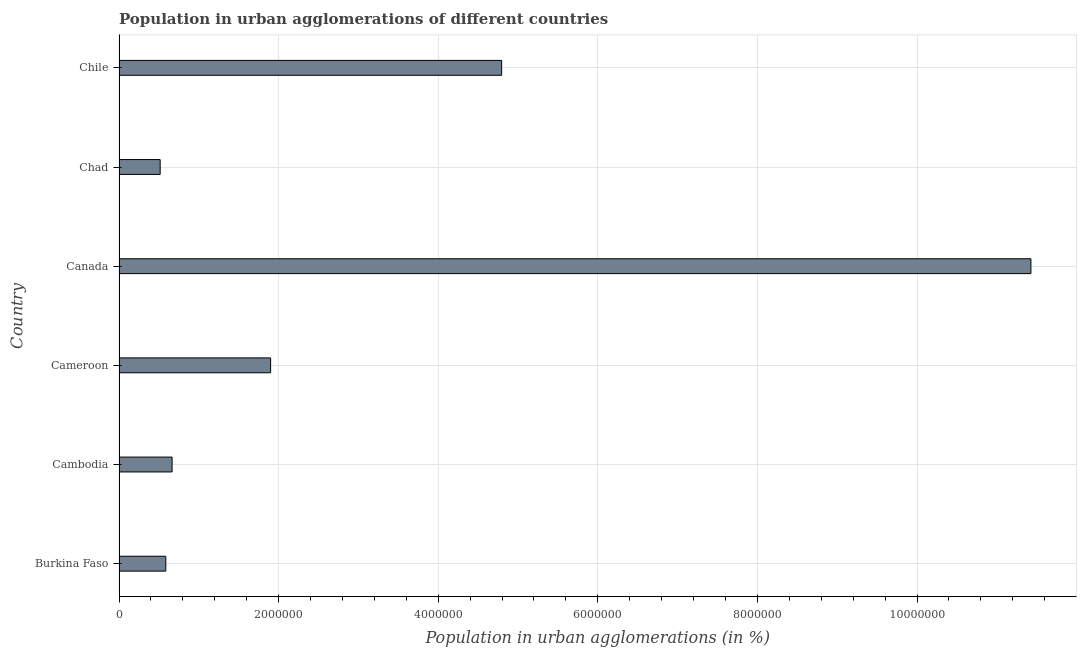Does the graph contain any zero values?
Offer a terse response. No. Does the graph contain grids?
Your answer should be compact. Yes. What is the title of the graph?
Keep it short and to the point. Population in urban agglomerations of different countries. What is the label or title of the X-axis?
Your answer should be very brief. Population in urban agglomerations (in %). What is the population in urban agglomerations in Cameroon?
Ensure brevity in your answer.  1.90e+06. Across all countries, what is the maximum population in urban agglomerations?
Provide a succinct answer. 1.14e+07. Across all countries, what is the minimum population in urban agglomerations?
Your response must be concise. 5.15e+05. In which country was the population in urban agglomerations minimum?
Ensure brevity in your answer.  Chad. What is the sum of the population in urban agglomerations?
Offer a terse response. 1.99e+07. What is the difference between the population in urban agglomerations in Cambodia and Chad?
Offer a very short reply. 1.49e+05. What is the average population in urban agglomerations per country?
Your answer should be very brief. 3.31e+06. What is the median population in urban agglomerations?
Ensure brevity in your answer.  1.28e+06. What is the ratio of the population in urban agglomerations in Burkina Faso to that in Chile?
Your answer should be compact. 0.12. Is the population in urban agglomerations in Canada less than that in Chile?
Give a very brief answer. No. What is the difference between the highest and the second highest population in urban agglomerations?
Provide a short and direct response. 6.63e+06. Is the sum of the population in urban agglomerations in Burkina Faso and Chile greater than the maximum population in urban agglomerations across all countries?
Offer a terse response. No. What is the difference between the highest and the lowest population in urban agglomerations?
Give a very brief answer. 1.09e+07. In how many countries, is the population in urban agglomerations greater than the average population in urban agglomerations taken over all countries?
Ensure brevity in your answer.  2. How many bars are there?
Make the answer very short. 6. Are all the bars in the graph horizontal?
Give a very brief answer. Yes. How many countries are there in the graph?
Provide a short and direct response. 6. Are the values on the major ticks of X-axis written in scientific E-notation?
Give a very brief answer. No. What is the Population in urban agglomerations (in %) of Burkina Faso?
Provide a short and direct response. 5.86e+05. What is the Population in urban agglomerations (in %) in Cambodia?
Your answer should be very brief. 6.65e+05. What is the Population in urban agglomerations (in %) of Cameroon?
Ensure brevity in your answer.  1.90e+06. What is the Population in urban agglomerations (in %) of Canada?
Ensure brevity in your answer.  1.14e+07. What is the Population in urban agglomerations (in %) in Chad?
Offer a very short reply. 5.15e+05. What is the Population in urban agglomerations (in %) in Chile?
Ensure brevity in your answer.  4.79e+06. What is the difference between the Population in urban agglomerations (in %) in Burkina Faso and Cambodia?
Make the answer very short. -7.88e+04. What is the difference between the Population in urban agglomerations (in %) in Burkina Faso and Cameroon?
Give a very brief answer. -1.31e+06. What is the difference between the Population in urban agglomerations (in %) in Burkina Faso and Canada?
Your answer should be compact. -1.08e+07. What is the difference between the Population in urban agglomerations (in %) in Burkina Faso and Chad?
Ensure brevity in your answer.  7.05e+04. What is the difference between the Population in urban agglomerations (in %) in Burkina Faso and Chile?
Your answer should be compact. -4.21e+06. What is the difference between the Population in urban agglomerations (in %) in Cambodia and Cameroon?
Offer a very short reply. -1.23e+06. What is the difference between the Population in urban agglomerations (in %) in Cambodia and Canada?
Give a very brief answer. -1.08e+07. What is the difference between the Population in urban agglomerations (in %) in Cambodia and Chad?
Provide a succinct answer. 1.49e+05. What is the difference between the Population in urban agglomerations (in %) in Cambodia and Chile?
Provide a short and direct response. -4.13e+06. What is the difference between the Population in urban agglomerations (in %) in Cameroon and Canada?
Offer a very short reply. -9.53e+06. What is the difference between the Population in urban agglomerations (in %) in Cameroon and Chad?
Ensure brevity in your answer.  1.38e+06. What is the difference between the Population in urban agglomerations (in %) in Cameroon and Chile?
Ensure brevity in your answer.  -2.90e+06. What is the difference between the Population in urban agglomerations (in %) in Canada and Chad?
Your answer should be compact. 1.09e+07. What is the difference between the Population in urban agglomerations (in %) in Canada and Chile?
Offer a terse response. 6.63e+06. What is the difference between the Population in urban agglomerations (in %) in Chad and Chile?
Provide a short and direct response. -4.28e+06. What is the ratio of the Population in urban agglomerations (in %) in Burkina Faso to that in Cambodia?
Provide a short and direct response. 0.88. What is the ratio of the Population in urban agglomerations (in %) in Burkina Faso to that in Cameroon?
Your answer should be very brief. 0.31. What is the ratio of the Population in urban agglomerations (in %) in Burkina Faso to that in Canada?
Your answer should be compact. 0.05. What is the ratio of the Population in urban agglomerations (in %) in Burkina Faso to that in Chad?
Give a very brief answer. 1.14. What is the ratio of the Population in urban agglomerations (in %) in Burkina Faso to that in Chile?
Your answer should be compact. 0.12. What is the ratio of the Population in urban agglomerations (in %) in Cambodia to that in Cameroon?
Provide a short and direct response. 0.35. What is the ratio of the Population in urban agglomerations (in %) in Cambodia to that in Canada?
Your response must be concise. 0.06. What is the ratio of the Population in urban agglomerations (in %) in Cambodia to that in Chad?
Ensure brevity in your answer.  1.29. What is the ratio of the Population in urban agglomerations (in %) in Cambodia to that in Chile?
Your answer should be very brief. 0.14. What is the ratio of the Population in urban agglomerations (in %) in Cameroon to that in Canada?
Provide a succinct answer. 0.17. What is the ratio of the Population in urban agglomerations (in %) in Cameroon to that in Chad?
Provide a succinct answer. 3.69. What is the ratio of the Population in urban agglomerations (in %) in Cameroon to that in Chile?
Give a very brief answer. 0.4. What is the ratio of the Population in urban agglomerations (in %) in Canada to that in Chad?
Provide a short and direct response. 22.17. What is the ratio of the Population in urban agglomerations (in %) in Canada to that in Chile?
Give a very brief answer. 2.38. What is the ratio of the Population in urban agglomerations (in %) in Chad to that in Chile?
Give a very brief answer. 0.11. 